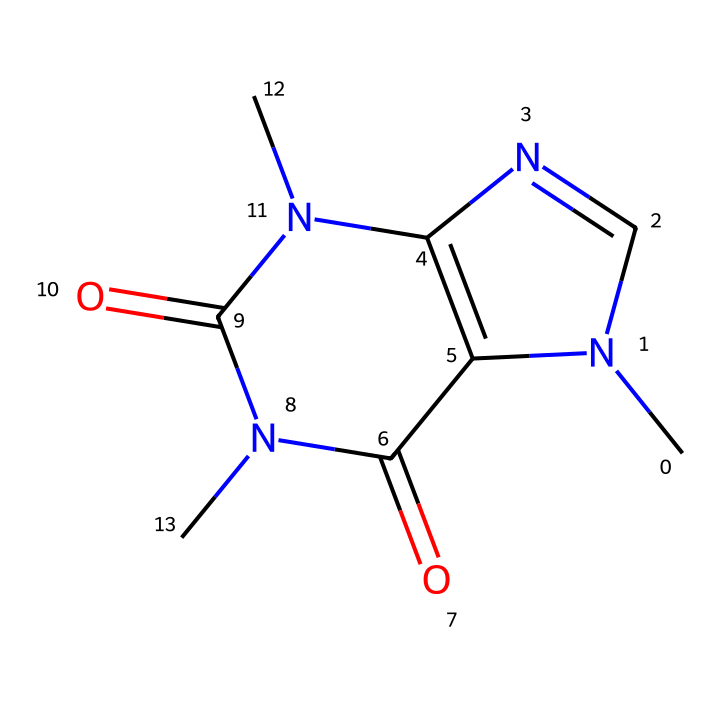What is the molecular formula of caffeine? The molecular formula can be determined by counting the number of each type of atom present in the SMILES representation. From the SMILES, we see 8 carbon atoms, 10 hydrogen atoms, 4 nitrogen atoms, and 2 oxygen atoms, leading to the formula C8H10N4O2.
Answer: C8H10N4O2 How many nitrogen atoms are in caffeine? By closely examining the SMILES representation, we can see four nitrogen atoms present in the structure. Thus, the answer is derived directly from counting the nitrogen atoms indicated in the SMILES.
Answer: 4 What functional groups are present in caffeine? Analyzing the SMILES structure, we can identify that caffeine contains two carbonyl functional groups (C=O), which are characteristic of ketones, and also implies the presence of amine groups due to the nitrogen atoms.
Answer: ketone and amine What type of compound is caffeine? Caffeine is categorized as an alkaloid, which can be inferred from the presence of nitrogen atoms in its structure and its biological effects. This classification is specific to its nitrogen-containing compound nature.
Answer: alkaloid How many rings are in the structure of caffeine? To determine the number of rings, we count the cyclic structures defined in the SMILES. Caffeine contains a double ring structure, defined by the connections between certain atoms.
Answer: 2 Describe the ketone functional groups present in caffeine. The ketone functional groups are identified by the presence of carbon atoms bonded to oxygen atoms via double bonds (C=O). In the SMILES for caffeine, we can specifically see that there are two such carbonyl groups, confirming the ketone classification.
Answer: 2 ketones What is the role of nitrogen in caffeine's structure? The nitrogen atoms in caffeine contribute to its overall stability and are responsible for its biological activity, such as its stimulant effect. In the structure, nitrogen impacts both electron distribution and hydrogen bonding capabilities, influencing caffeine's behavior in biological systems.
Answer: stability and activity 